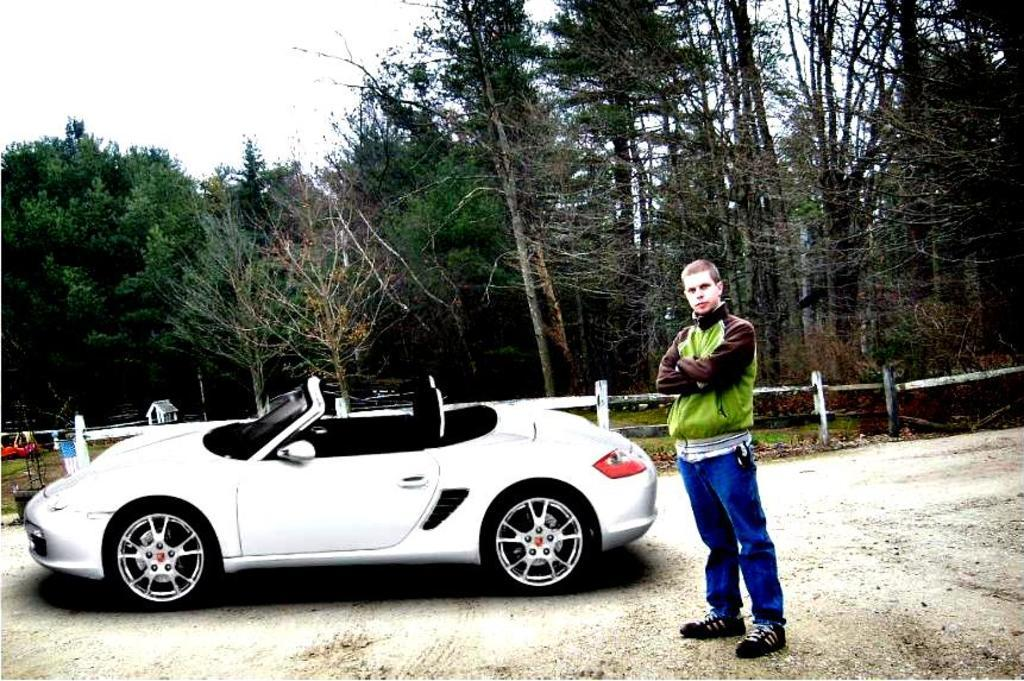What is the main subject of the image? There is a car in the image. Who or what else can be seen in the image? There is a man standing on the ground in the image. What can be seen in the background of the image? There are objects, a fence, trees, and the sky visible in the background of the image. What is the condition of the sky in the image? Clouds are present in the sky. What type of eggnog is being served in the image? There is no eggnog present in the image. What color are the trousers worn by the man in the image? The provided facts do not mention the color or type of clothing worn by the man in the image. 